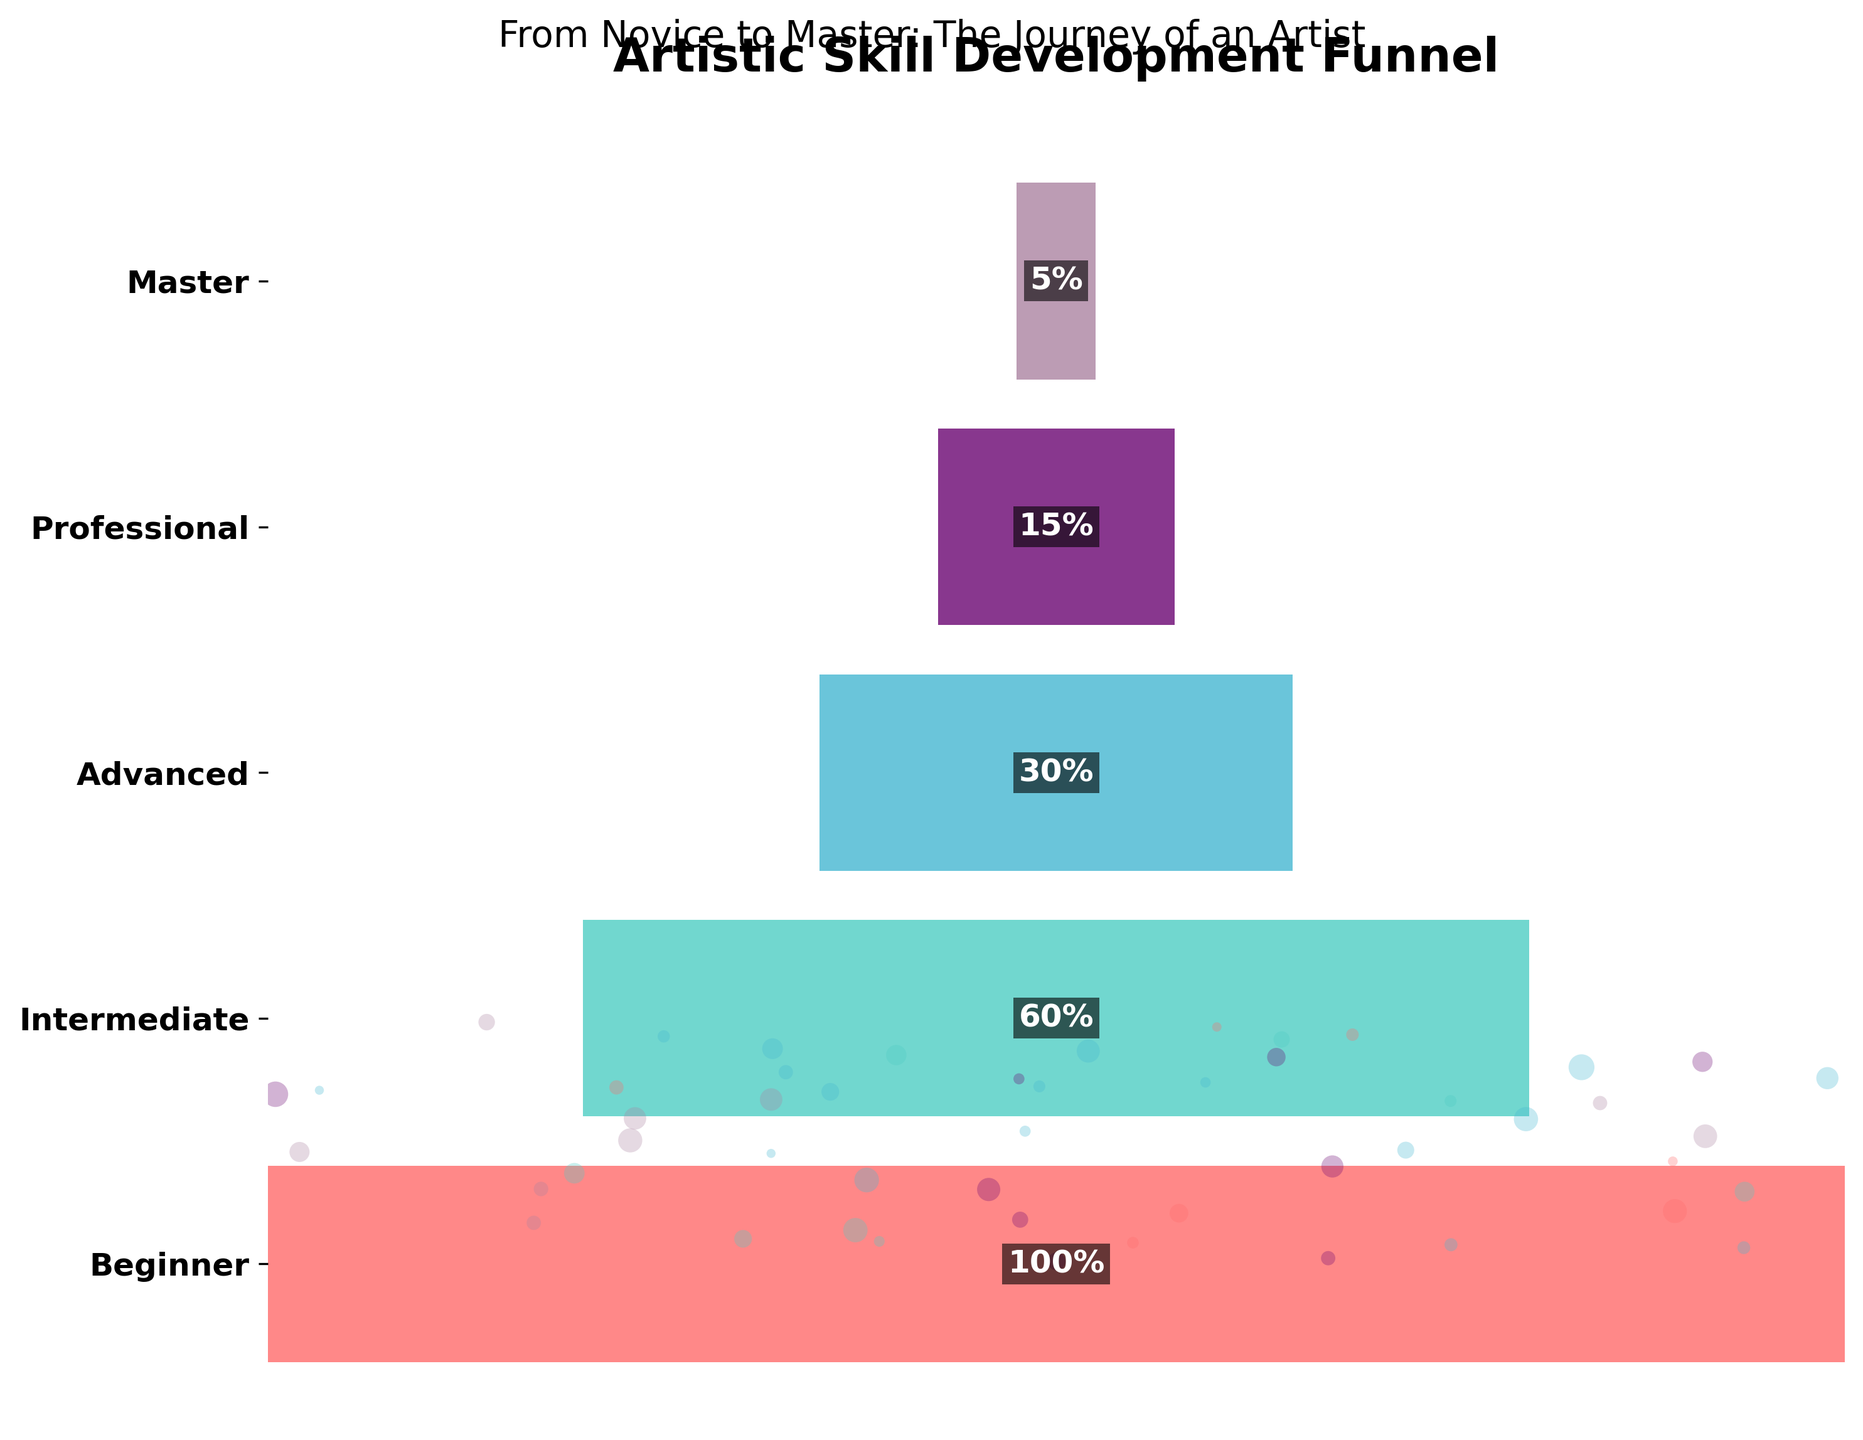What is the title of the figure? The title of the figure is located at the top and typically serves as an overview of what the chart represents. Here, it is "Artistic Skill Development Funnel".
Answer: Artistic Skill Development Funnel Which stage has the highest percentage of artists? The funnel chart's widest portion represents the stage with the highest percentage, which at the top shows "Beginner" with 100%.
Answer: Beginner What is the percentage of artists at the Professional stage? By reading the chart, we can notice the percentage is mentioned within each segment. The Professional stage has 15%.
Answer: 15% How many levels of artistic skill development are depicted in the chart? By counting the distinct sections of the funnel from top to bottom, each labeled with a stage, we can see there are five levels: Beginner, Intermediate, Advanced, Professional, and Master.
Answer: 5 What is the total percentage drop from Beginner to Master? Subtract the percentage of the Master stage from the percentage of the Beginner stage: 100% (Beginner) - 5% (Master) = 95%.
Answer: 95% How does the percentage of artists at the Advanced stage compare to those at the Intermediate stage? Since the funnel for Advanced is distinctly narrower than Intermediate, we can see that the percentage of artists at Advanced (30%) is smaller than Intermediate (60%).
Answer: Smaller By what factor is the percentage of Intermediate artists larger than the percentage of Master artists? To find the factor, divide the Intermediate percentage by the Master percentage: 60% / 5% = 12.
Answer: 12 Which stage shows the sharpest drop in percentage of artists when moving to the next stage? By comparing the drops between stages, the sharpest drop is from Intermediate (60%) to Advanced (30%), which is a 30% drop.
Answer: Intermediate to Advanced If each artist represents an equal portion, how much more saturated is the Beginner stage compared to the Professional stage in percentage terms? Divide the percentage of Beginners by the percentage of Professionals: 100% / 15% = 6.67. Therefore, the Beginner stage is 6.67 times more saturated than the Professional stage.
Answer: 6.67 What message does the overall shape of the funnel convey about artistic skill development? The funnel narrows down sharply, especially after Intermediate, indicating that fewer artists reach higher levels, suggesting that advancing in artistic skill is progressively challenging.
Answer: Progressive challenge in advancing levels 